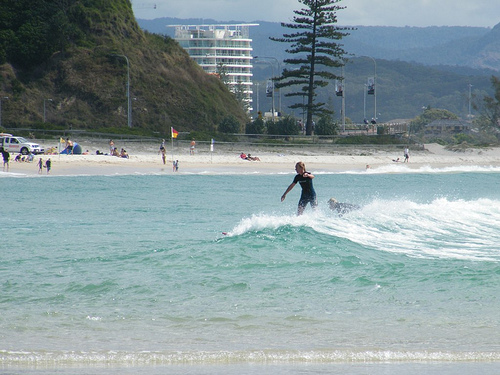Please provide the bounding box coordinate of the region this sentence describes: A vehicle is on a beach. The bounding box coordinates for the vehicle on the beach are [0.0, 0.38, 0.09, 0.44]. These coordinates focus on the region containing the vehicle on the beach area. 